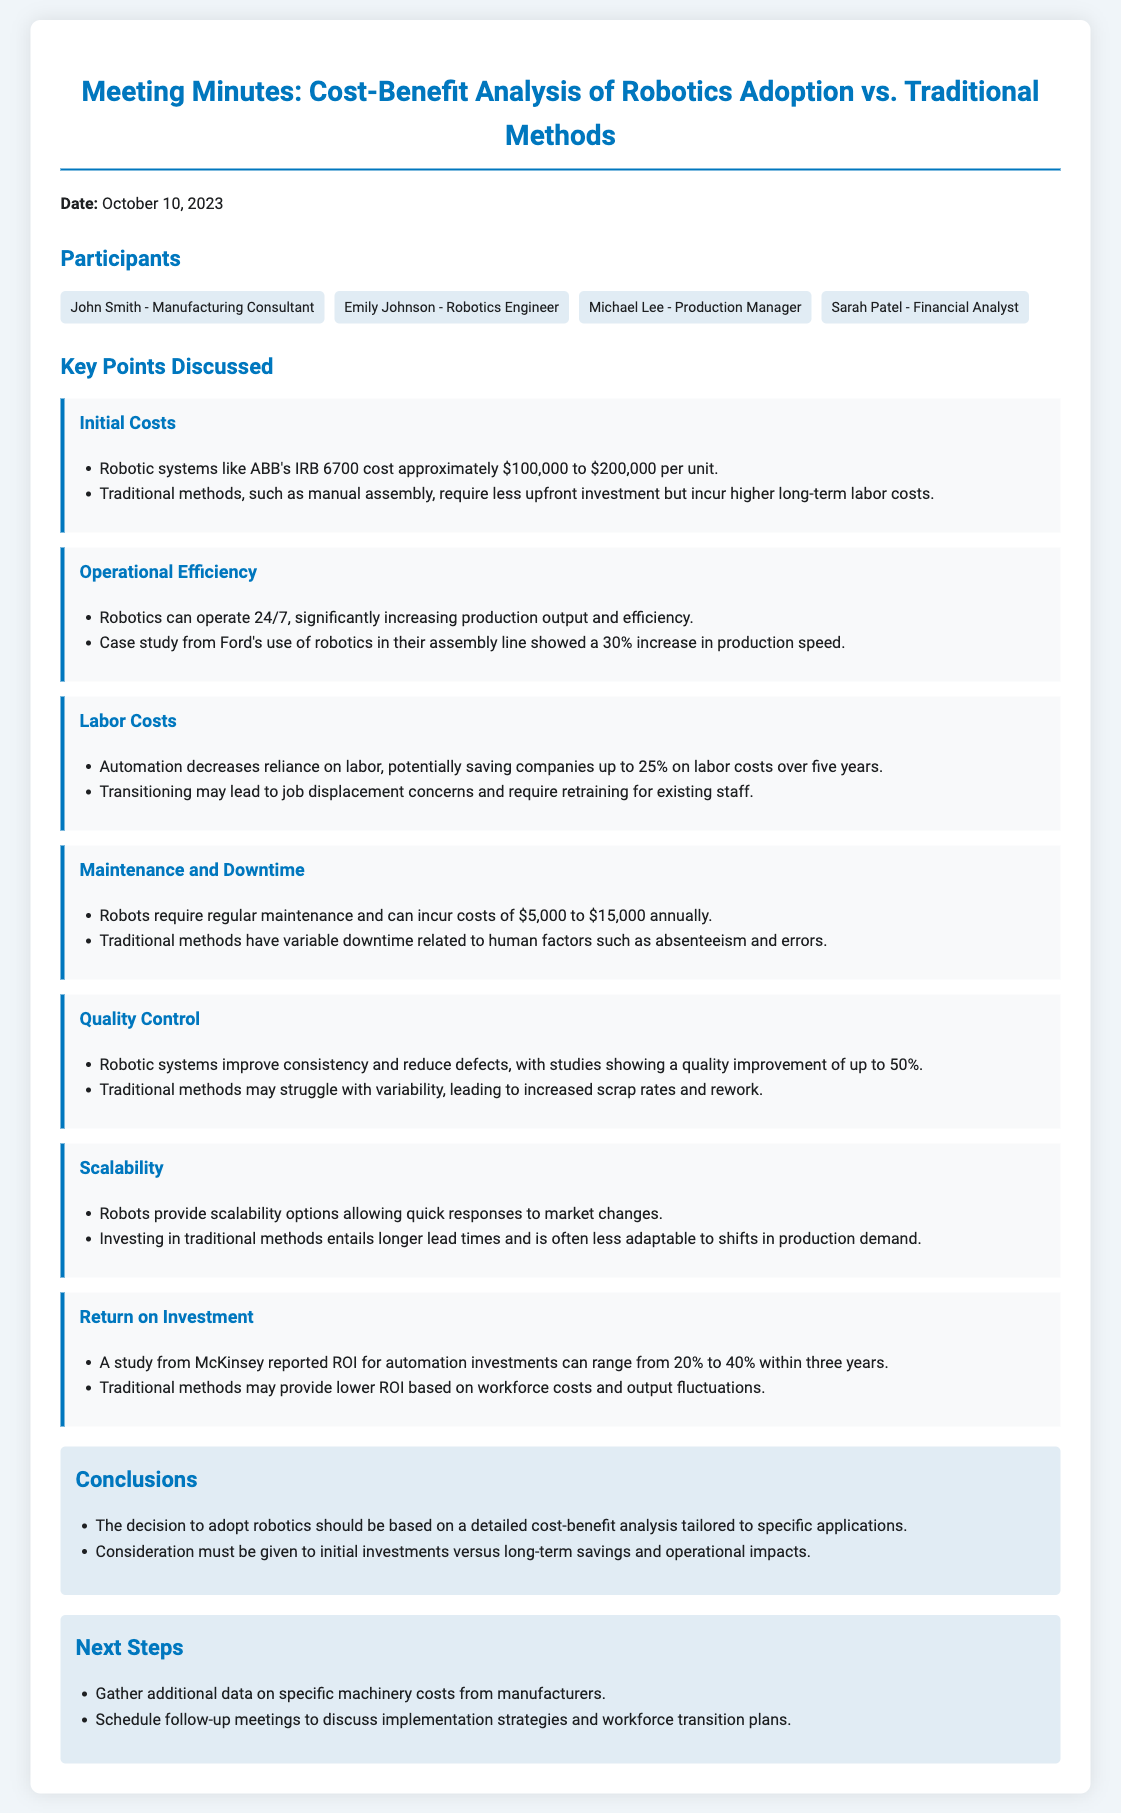what is the date of the meeting? The date of the meeting is mentioned in the first paragraph, which is October 10, 2023.
Answer: October 10, 2023 who presented the initial costs of robotics? The initial costs were discussed, mentioned in the key points section, attributed to the participants in the meeting without specific mention of an individual.
Answer: Not specified what is the estimated cost range for robotic systems? The estimated cost range for robotic systems is provided in the initial costs section, which states approximately $100,000 to $200,000 per unit.
Answer: $100,000 to $200,000 what percentage increase in production speed did Ford experience from robotics? The percentage increase in production speed, highlighted in the operational efficiency section, is 30%.
Answer: 30% how much can automation potentially save on labor costs over five years? The potential savings from automation is stated in the labor costs section, which mentions up to 25% savings on labor costs over five years.
Answer: 25% what is the annual maintenance cost range for robots? The annual maintenance cost range for robots, noted in the maintenance and downtime section, is between $5,000 and $15,000.
Answer: $5,000 to $15,000 what conclusion is drawn about the adoption of robotics? The conclusion regarding robotics adoption is indicated in the conclusions section, emphasizing the need for a detailed cost-benefit analysis tailored to specific applications.
Answer: Detailed cost-benefit analysis what is the return on investment range for automation investments? The return on investment range for automation investments is mentioned in the return on investment section, which states between 20% to 40% within three years.
Answer: 20% to 40% what are the next steps mentioned in the meeting minutes? The next steps are detailed in the next steps section as gathering additional data on machinery costs and scheduling follow-up meetings.
Answer: Gather additional data and schedule follow-up meetings 